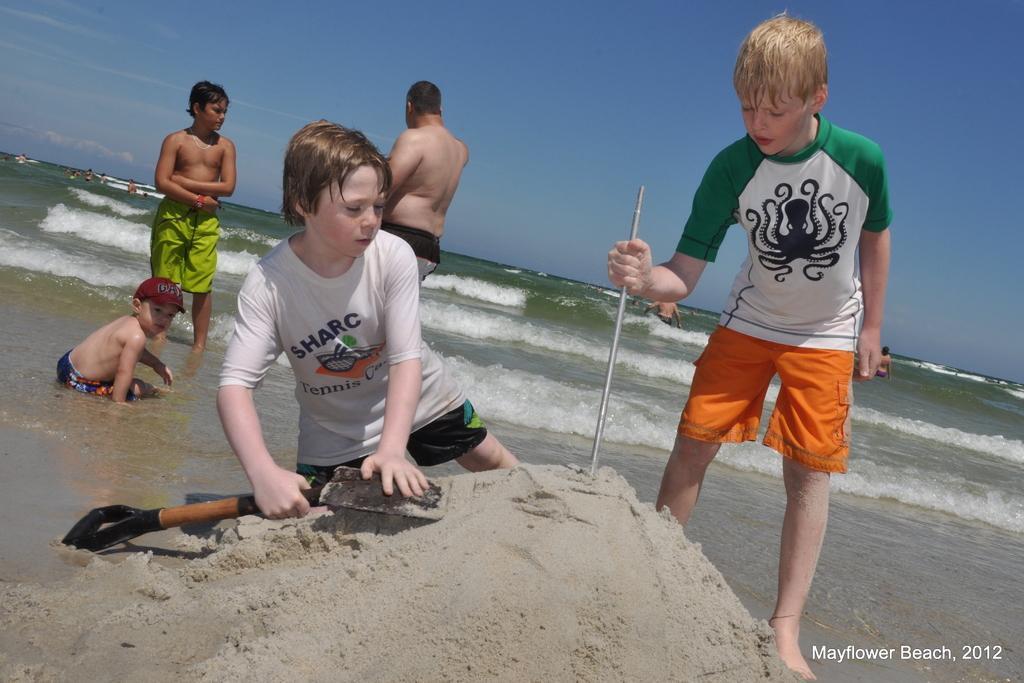Can you describe this image briefly? There are people and these two boys holding tools and we can see sand. In the background we can see water,people and sky in blue color. In the bottom right side of the image we can see text. 